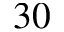<formula> <loc_0><loc_0><loc_500><loc_500>3 0</formula> 